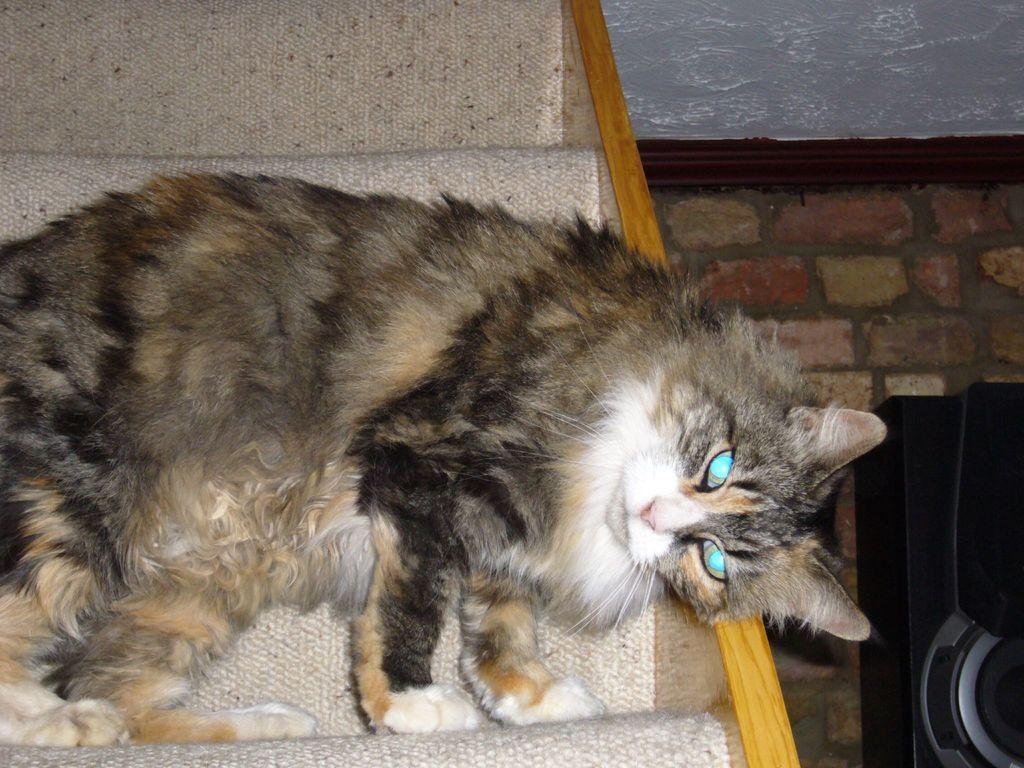What type of animal is in the image? There is a cat in the image. Where is the cat located in the image? The cat is on the left side of the image. What is on the opposite side of the cat in the image? There is a wall on the right side of the image. How many chickens are present on the wall in the image? There are no chickens present in the image; it features a cat and a wall. What type of paste is being used by the achiever in the image? There is no achiever or paste present in the image. 